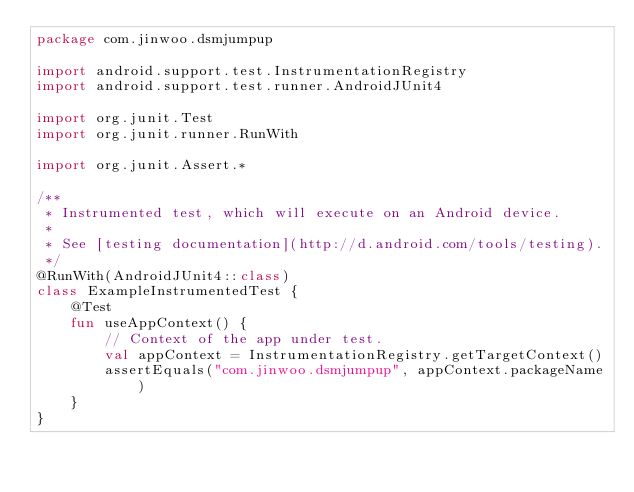Convert code to text. <code><loc_0><loc_0><loc_500><loc_500><_Kotlin_>package com.jinwoo.dsmjumpup

import android.support.test.InstrumentationRegistry
import android.support.test.runner.AndroidJUnit4

import org.junit.Test
import org.junit.runner.RunWith

import org.junit.Assert.*

/**
 * Instrumented test, which will execute on an Android device.
 *
 * See [testing documentation](http://d.android.com/tools/testing).
 */
@RunWith(AndroidJUnit4::class)
class ExampleInstrumentedTest {
    @Test
    fun useAppContext() {
        // Context of the app under test.
        val appContext = InstrumentationRegistry.getTargetContext()
        assertEquals("com.jinwoo.dsmjumpup", appContext.packageName)
    }
}
</code> 